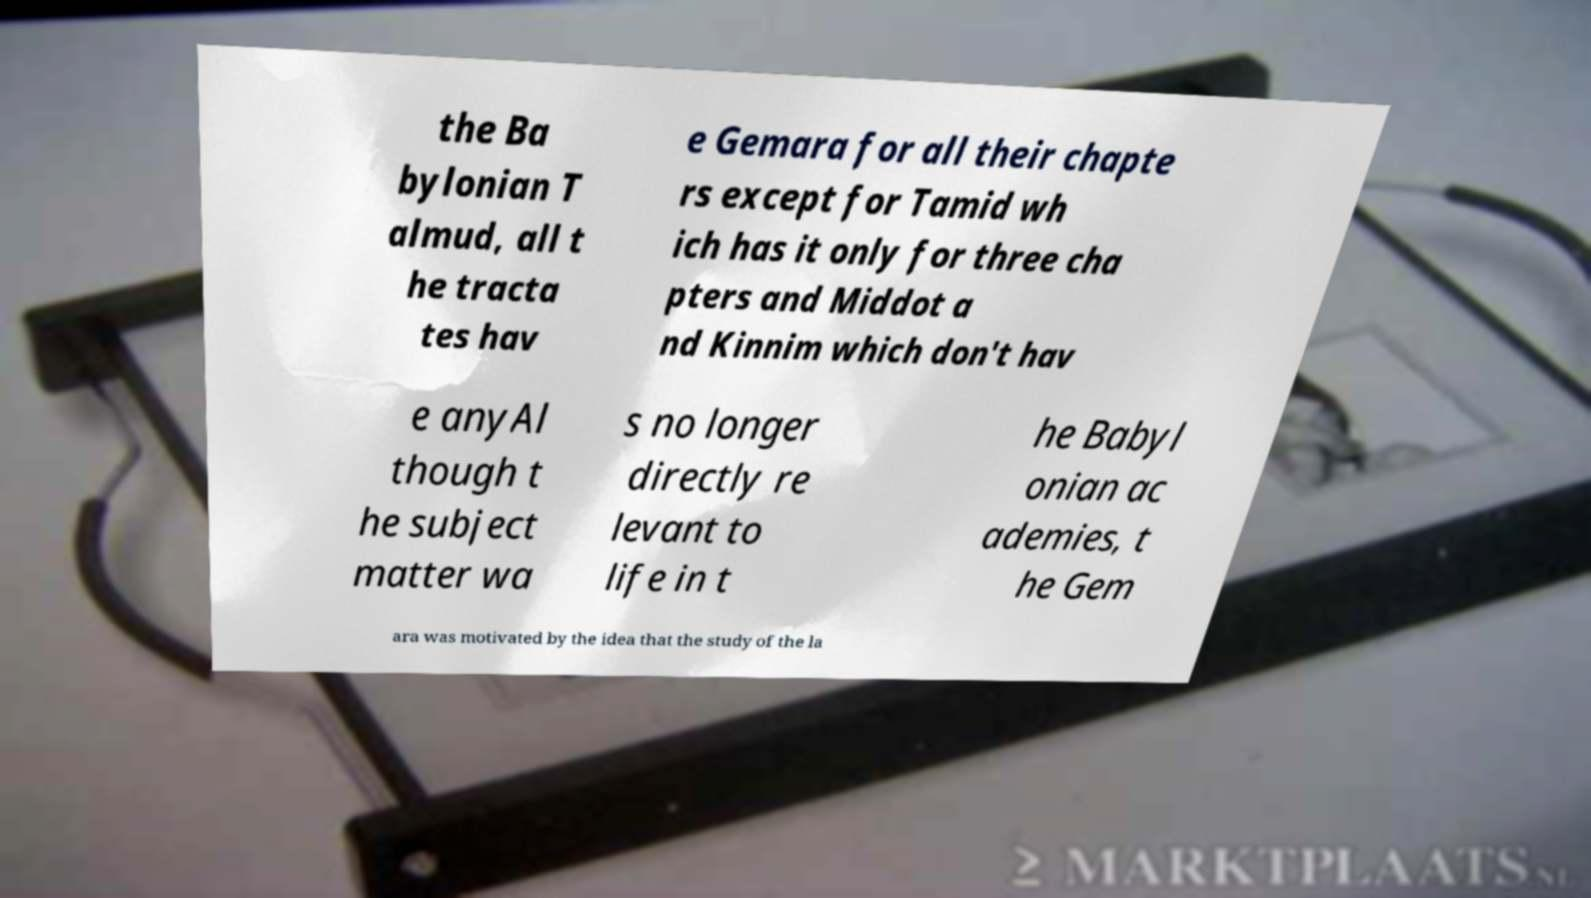Please identify and transcribe the text found in this image. the Ba bylonian T almud, all t he tracta tes hav e Gemara for all their chapte rs except for Tamid wh ich has it only for three cha pters and Middot a nd Kinnim which don't hav e anyAl though t he subject matter wa s no longer directly re levant to life in t he Babyl onian ac ademies, t he Gem ara was motivated by the idea that the study of the la 